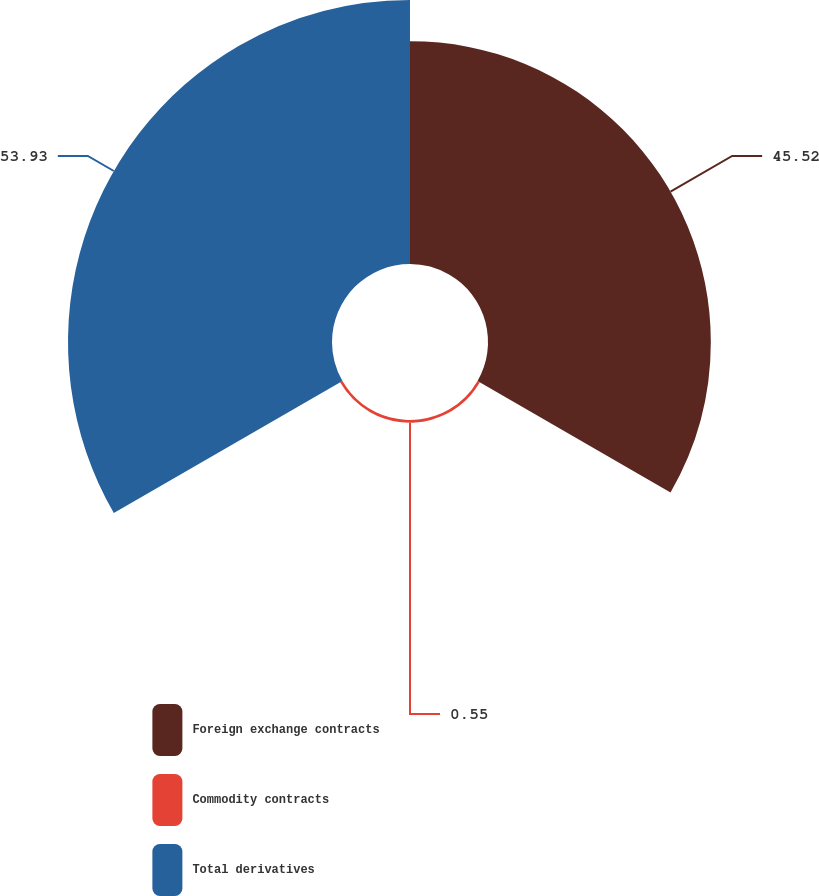Convert chart to OTSL. <chart><loc_0><loc_0><loc_500><loc_500><pie_chart><fcel>Foreign exchange contracts<fcel>Commodity contracts<fcel>Total derivatives<nl><fcel>45.52%<fcel>0.55%<fcel>53.93%<nl></chart> 